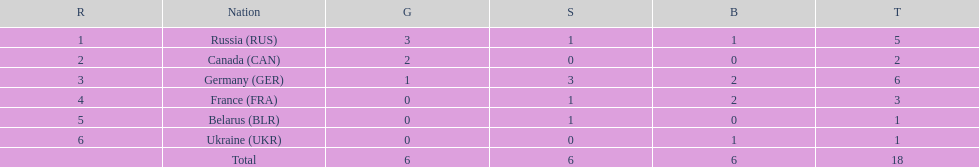What was the total number of silver medals awarded to the french and the germans in the 1994 winter olympic biathlon? 4. 